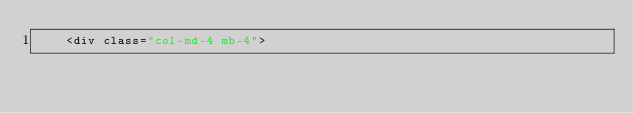Convert code to text. <code><loc_0><loc_0><loc_500><loc_500><_PHP_>    <div class="col-md-4 mb-4"></code> 